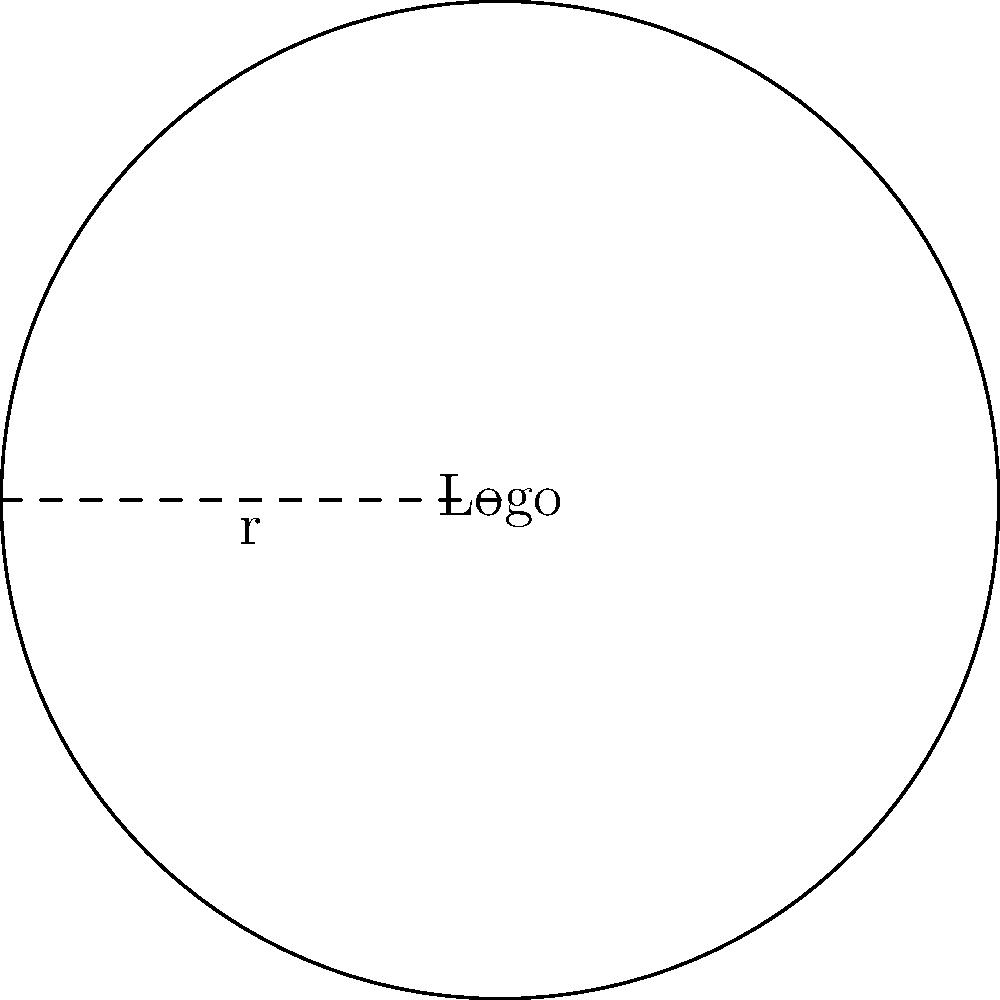Your startup's circular logo has a radius of 5 cm. To ensure proper scaling for various marketing materials, you need to calculate the logo's area. What is the area of the logo in square centimeters? To calculate the area of a circular logo, we use the formula for the area of a circle:

$$A = \pi r^2$$

Where:
$A$ is the area
$\pi$ (pi) is approximately 3.14159
$r$ is the radius

Given:
Radius $(r) = 5$ cm

Step 1: Substitute the radius into the formula.
$$A = \pi (5\text{ cm})^2$$

Step 2: Calculate the square of the radius.
$$A = \pi (25\text{ cm}^2)$$

Step 3: Multiply by $\pi$.
$$A = 78.54\text{ cm}^2$$ (rounded to two decimal places)

Therefore, the area of the startup's circular logo is approximately 78.54 square centimeters.
Answer: $78.54\text{ cm}^2$ 